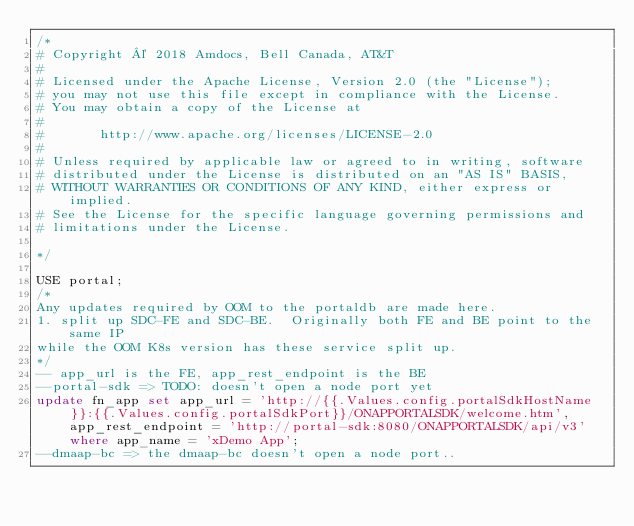Convert code to text. <code><loc_0><loc_0><loc_500><loc_500><_SQL_>/*
# Copyright © 2018 Amdocs, Bell Canada, AT&T
#
# Licensed under the Apache License, Version 2.0 (the "License");
# you may not use this file except in compliance with the License.
# You may obtain a copy of the License at
#
#       http://www.apache.org/licenses/LICENSE-2.0
#
# Unless required by applicable law or agreed to in writing, software
# distributed under the License is distributed on an "AS IS" BASIS,
# WITHOUT WARRANTIES OR CONDITIONS OF ANY KIND, either express or implied.
# See the License for the specific language governing permissions and
# limitations under the License.

*/

USE portal;
/*
Any updates required by OOM to the portaldb are made here.
1. split up SDC-FE and SDC-BE.  Originally both FE and BE point to the same IP
while the OOM K8s version has these service split up.
*/
-- app_url is the FE, app_rest_endpoint is the BE
--portal-sdk => TODO: doesn't open a node port yet
update fn_app set app_url = 'http://{{.Values.config.portalSdkHostName}}:{{.Values.config.portalSdkPort}}/ONAPPORTALSDK/welcome.htm', app_rest_endpoint = 'http://portal-sdk:8080/ONAPPORTALSDK/api/v3' where app_name = 'xDemo App';
--dmaap-bc => the dmaap-bc doesn't open a node port..</code> 